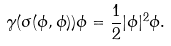<formula> <loc_0><loc_0><loc_500><loc_500>\gamma ( \sigma ( \phi , \phi ) ) \phi = \frac { 1 } { 2 } | \phi | ^ { 2 } \phi .</formula> 